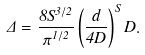<formula> <loc_0><loc_0><loc_500><loc_500>\Delta = \frac { 8 S ^ { 3 / 2 } } { \pi ^ { 1 / 2 } } \left ( \frac { d } { 4 D } \right ) ^ { S } D .</formula> 